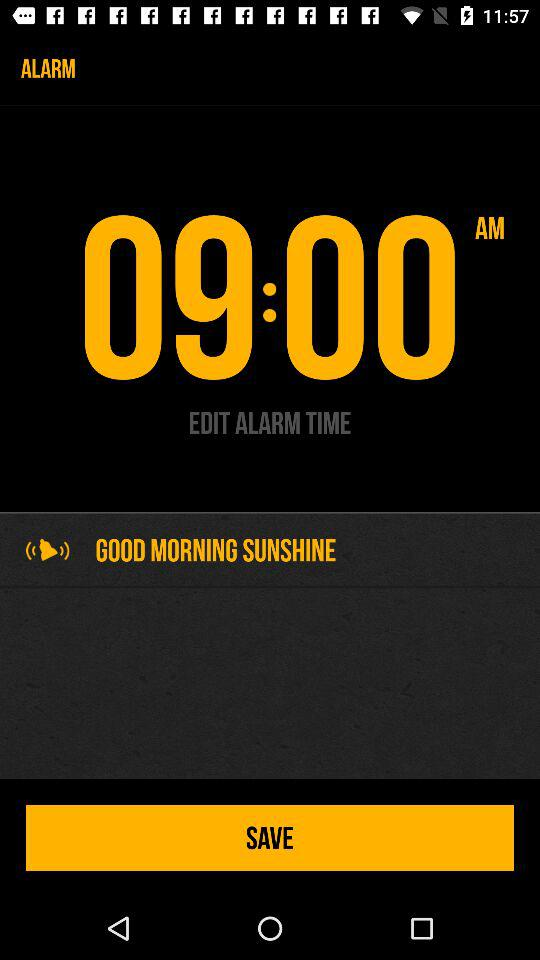What is the selected time of alarm? The time of alarm is 09:00 AM. 